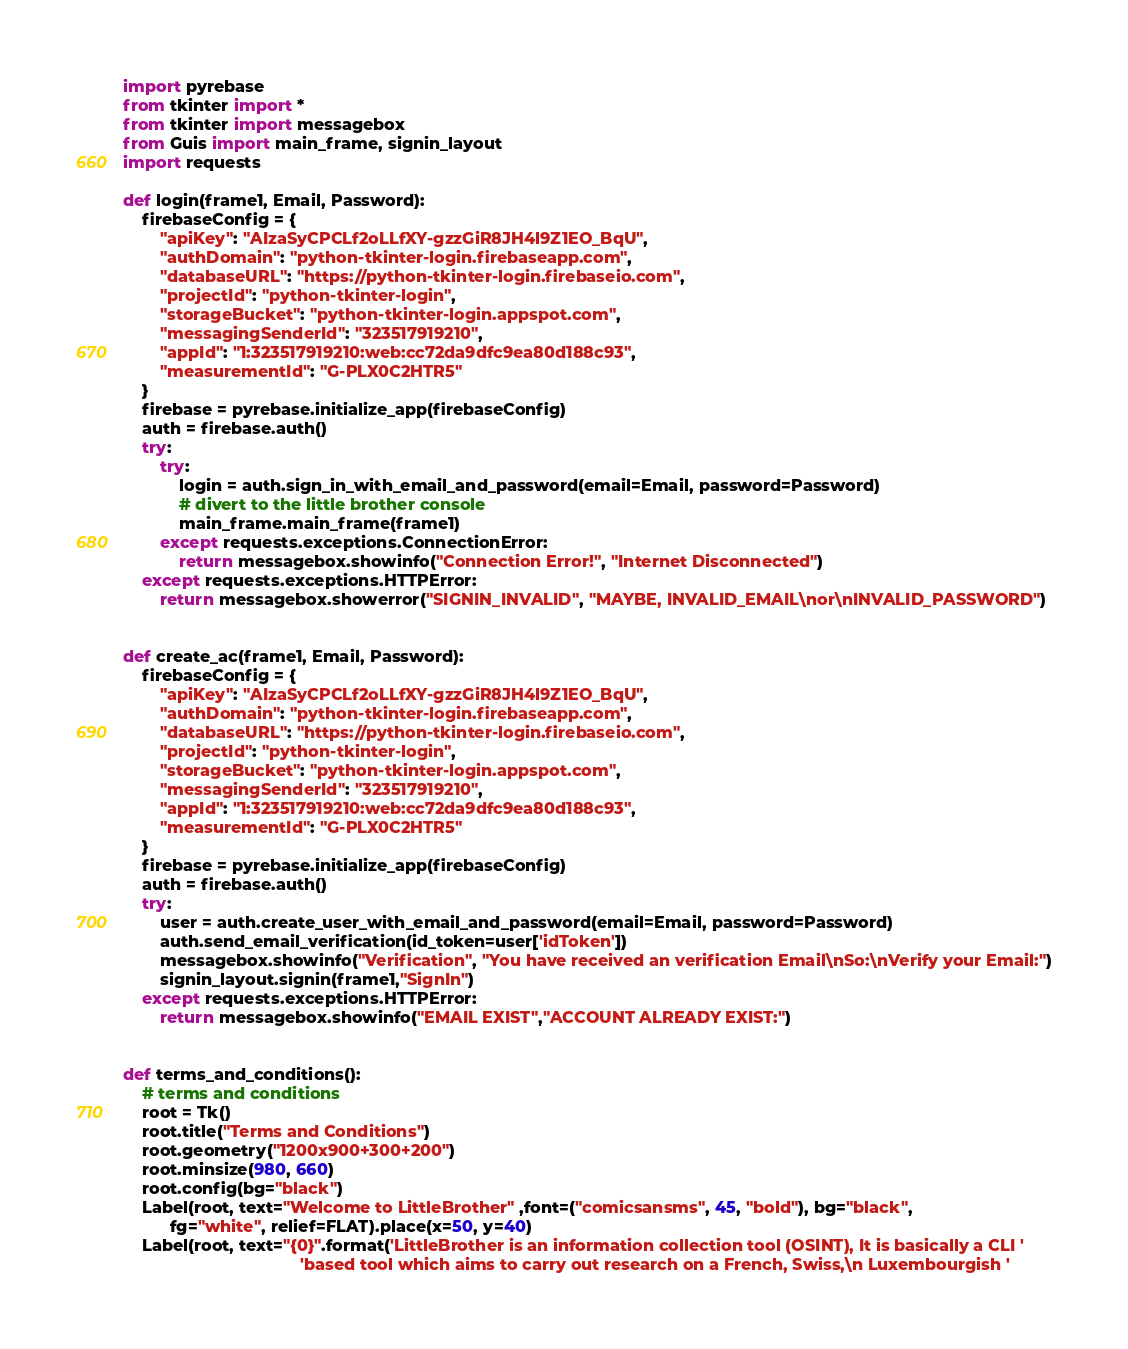<code> <loc_0><loc_0><loc_500><loc_500><_Python_>import pyrebase
from tkinter import *
from tkinter import messagebox
from Guis import main_frame, signin_layout
import requests

def login(frame1, Email, Password):
    firebaseConfig = {
        "apiKey": "AIzaSyCPCLf2oLLfXY-gzzGiR8JH4l9Z1EO_BqU",
        "authDomain": "python-tkinter-login.firebaseapp.com",
        "databaseURL": "https://python-tkinter-login.firebaseio.com",
        "projectId": "python-tkinter-login",
        "storageBucket": "python-tkinter-login.appspot.com",
        "messagingSenderId": "323517919210",
        "appId": "1:323517919210:web:cc72da9dfc9ea80d188c93",
        "measurementId": "G-PLX0C2HTR5"
    }
    firebase = pyrebase.initialize_app(firebaseConfig)
    auth = firebase.auth()
    try:
        try:
            login = auth.sign_in_with_email_and_password(email=Email, password=Password)
            # divert to the little brother console
            main_frame.main_frame(frame1)
        except requests.exceptions.ConnectionError:
            return messagebox.showinfo("Connection Error!", "Internet Disconnected")
    except requests.exceptions.HTTPError:
        return messagebox.showerror("SIGNIN_INVALID", "MAYBE, INVALID_EMAIL\nor\nINVALID_PASSWORD")


def create_ac(frame1, Email, Password):
    firebaseConfig = {
        "apiKey": "AIzaSyCPCLf2oLLfXY-gzzGiR8JH4l9Z1EO_BqU",
        "authDomain": "python-tkinter-login.firebaseapp.com",
        "databaseURL": "https://python-tkinter-login.firebaseio.com",
        "projectId": "python-tkinter-login",
        "storageBucket": "python-tkinter-login.appspot.com",
        "messagingSenderId": "323517919210",
        "appId": "1:323517919210:web:cc72da9dfc9ea80d188c93",
        "measurementId": "G-PLX0C2HTR5"
    }
    firebase = pyrebase.initialize_app(firebaseConfig)
    auth = firebase.auth()
    try:
        user = auth.create_user_with_email_and_password(email=Email, password=Password)
        auth.send_email_verification(id_token=user['idToken'])
        messagebox.showinfo("Verification", "You have received an verification Email\nSo:\nVerify your Email:")
        signin_layout.signin(frame1,"SignIn")
    except requests.exceptions.HTTPError:
        return messagebox.showinfo("EMAIL EXIST","ACCOUNT ALREADY EXIST:")


def terms_and_conditions():
    # terms and conditions
    root = Tk()
    root.title("Terms and Conditions")
    root.geometry("1200x900+300+200")
    root.minsize(980, 660)
    root.config(bg="black")
    Label(root, text="Welcome to LittleBrother" ,font=("comicsansms", 45, "bold"), bg="black",
          fg="white", relief=FLAT).place(x=50, y=40)
    Label(root, text="{0}".format('LittleBrother is an information collection tool (OSINT), It is basically a CLI '
                                      'based tool which aims to carry out research on a French, Swiss,\n Luxembourgish '</code> 